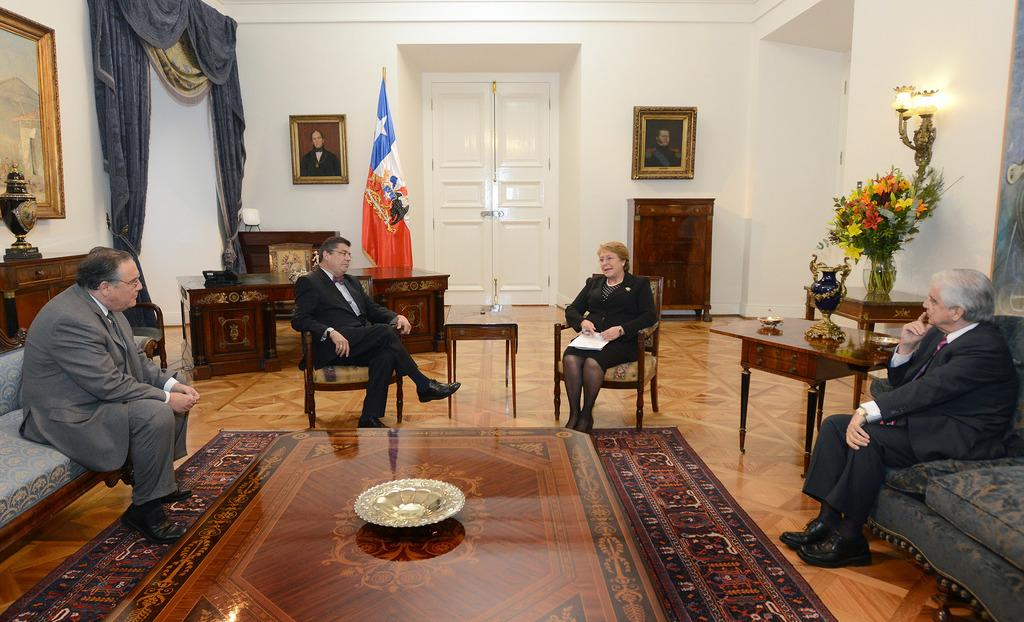How many people are present in the image? There are four people in the image. What are the people doing in the image? The people are seated on chairs. Can you describe the woman in the image? The woman is holding a paper in her hand. What can be seen in the background of the image? There is a flag and photo frames on the wall. What is on the table in the image? There is a flower vase on a table. What type of tree can be seen in the image? There is no tree present in the image. What is the woman's reaction to the fear in the image? There is no fear or indication of fear in the image. 